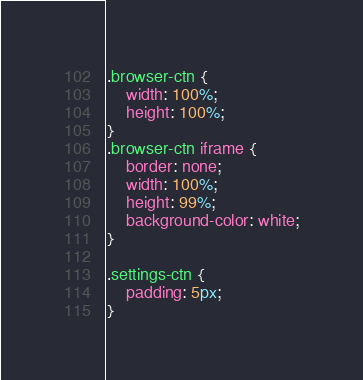<code> <loc_0><loc_0><loc_500><loc_500><_CSS_>
.browser-ctn {
	width: 100%;
	height: 100%;
}
.browser-ctn iframe {
	border: none;
	width: 100%;
	height: 99%;
	background-color: white;
}

.settings-ctn {
	padding: 5px;
}</code> 